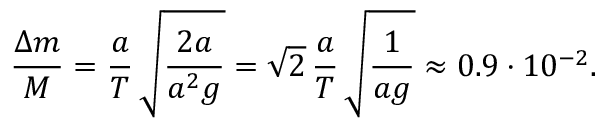<formula> <loc_0><loc_0><loc_500><loc_500>\frac { \Delta m } { M } = \frac { a } { T } \, \sqrt { \frac { 2 a } { a ^ { 2 } g } } = \sqrt { 2 } \, \frac { a } { T } \, \sqrt { \frac { 1 } { a g } } \approx 0 . 9 \cdot 1 0 ^ { - 2 } .</formula> 